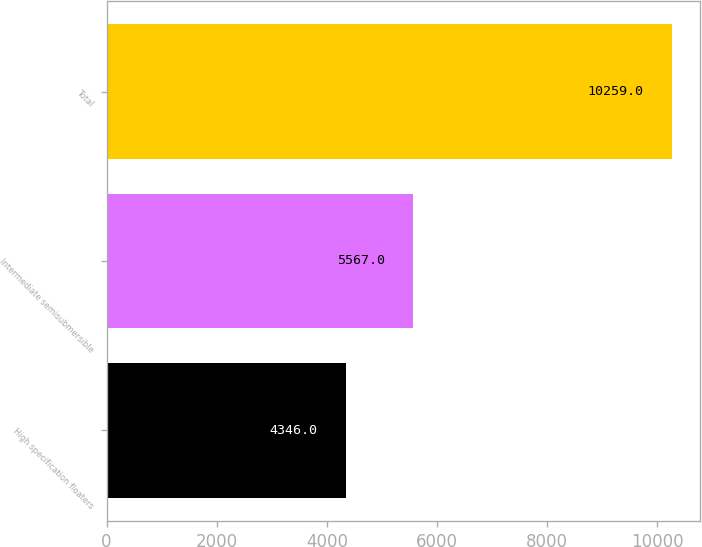<chart> <loc_0><loc_0><loc_500><loc_500><bar_chart><fcel>High specification floaters<fcel>Intermediate semisubmersible<fcel>Total<nl><fcel>4346<fcel>5567<fcel>10259<nl></chart> 